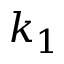<formula> <loc_0><loc_0><loc_500><loc_500>k _ { 1 }</formula> 